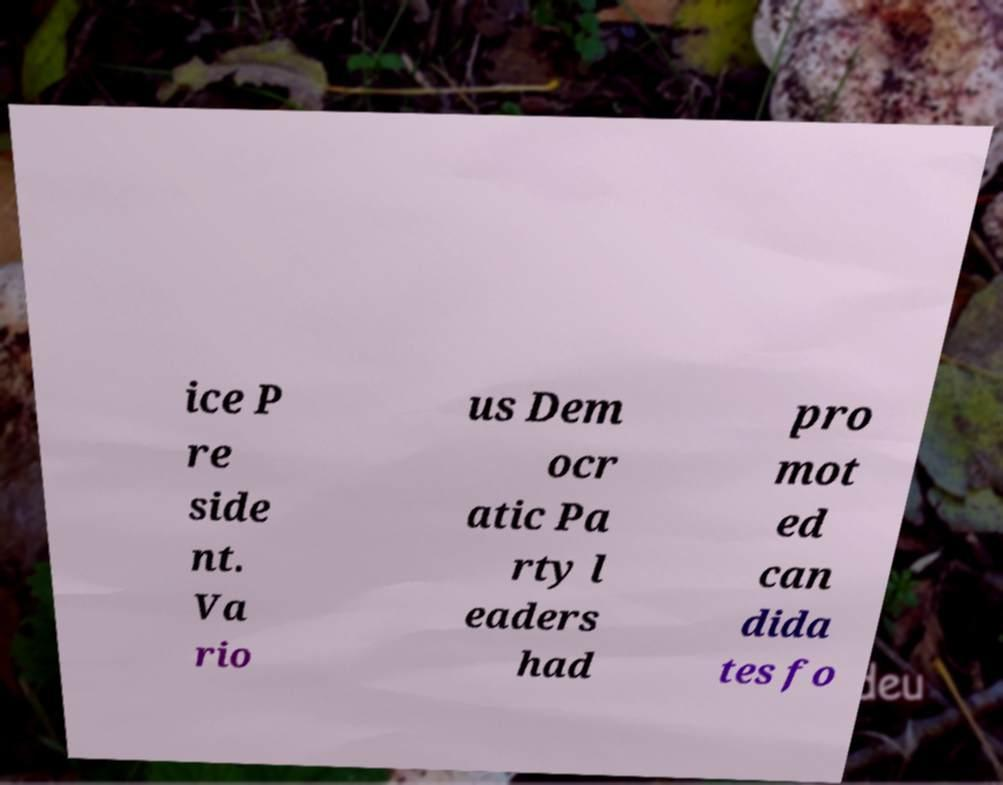Please identify and transcribe the text found in this image. ice P re side nt. Va rio us Dem ocr atic Pa rty l eaders had pro mot ed can dida tes fo 